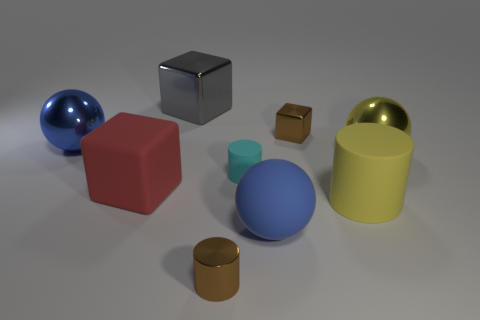Subtract all large shiny spheres. How many spheres are left? 1 Subtract all blue spheres. How many spheres are left? 1 Subtract 1 cylinders. How many cylinders are left? 2 Subtract 0 cyan blocks. How many objects are left? 9 Subtract all blocks. How many objects are left? 6 Subtract all cyan blocks. Subtract all red balls. How many blocks are left? 3 Subtract all blue blocks. How many green spheres are left? 0 Subtract all yellow blocks. Subtract all tiny cubes. How many objects are left? 8 Add 9 tiny brown metal cubes. How many tiny brown metal cubes are left? 10 Add 5 tiny red metal objects. How many tiny red metal objects exist? 5 